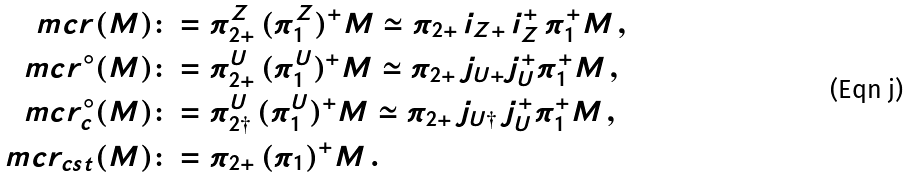<formula> <loc_0><loc_0><loc_500><loc_500>\ m c r ( M ) & \colon = \pi ^ { Z } _ { 2 + } \, ( \pi ^ { Z } _ { 1 } ) ^ { + } M \simeq \pi _ { 2 + } \, i _ { Z + } \, i _ { Z } ^ { + } \, \pi _ { 1 } ^ { + } M \, , \\ \ m c r ^ { \circ } ( M ) & \colon = \pi ^ { U } _ { 2 + } \, ( \pi ^ { U } _ { 1 } ) ^ { + } M \simeq \pi _ { 2 + } \, j _ { U + } j ^ { + } _ { U } \pi _ { 1 } ^ { + } M \, , \\ \ m c r ^ { \circ } _ { c } ( M ) & \colon = \pi ^ { U } _ { 2 \dag } \, ( \pi ^ { U } _ { 1 } ) ^ { + } M \simeq \pi _ { 2 + } \, j _ { U \dag } \, j ^ { + } _ { U } \pi _ { 1 } ^ { + } M \, , \\ \ m c r _ { c s t } ( M ) & \colon = \pi _ { 2 + } \, ( \pi _ { 1 } ) ^ { + } M \, .</formula> 